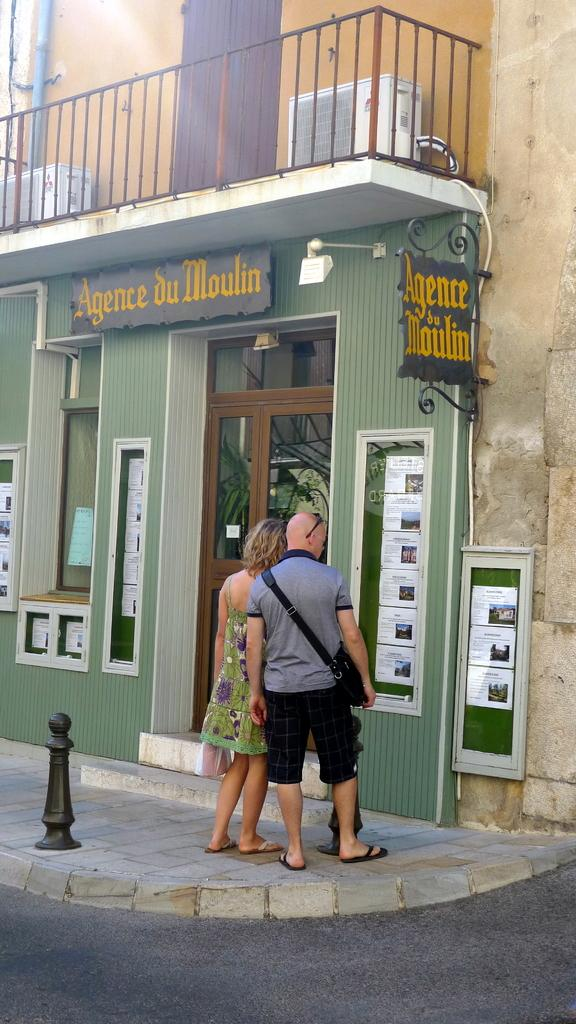Who are the two people in the center of the image? There is a man and a woman in the center of the image. What is the surface they are standing on? They are standing on the ground. What can be seen in the background of the image? There is a door, windows, and a building in the background of the image. What type of worm can be seen crawling on the man's shoulder in the image? There is no worm present in the image; the man and woman are the only subjects visible. 